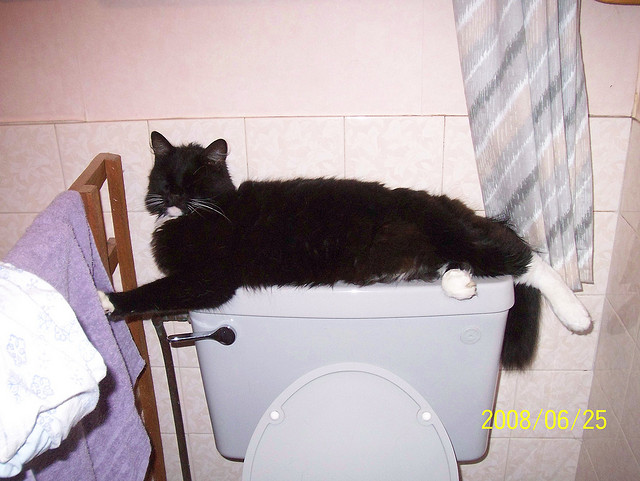Identify the text contained in this image. 2008 06 25 